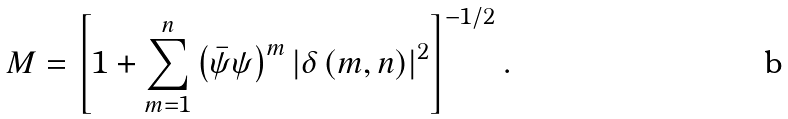Convert formula to latex. <formula><loc_0><loc_0><loc_500><loc_500>M = \left [ 1 + \underset { m = 1 } { \overset { n } { \sum } } \left ( \bar { \psi } \psi \right ) ^ { m } \left | \delta \left ( m , n \right ) \right | ^ { 2 } \right ] ^ { - 1 / 2 } .</formula> 